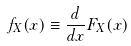Convert formula to latex. <formula><loc_0><loc_0><loc_500><loc_500>f _ { X } ( x ) \equiv \frac { d } { d x } F _ { X } ( x )</formula> 